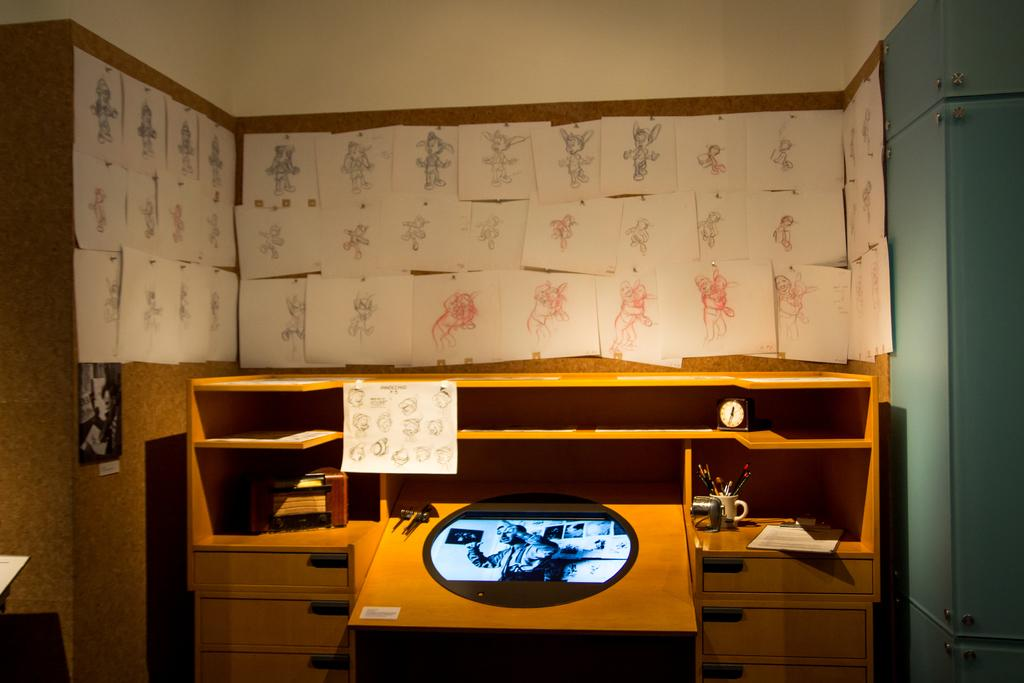What type of table is visible in the image? There is a wooden table in the image. What is on the table in the image? There are objects on the table. What can be seen on the wall in the background of the image? There are posters on the wall in the background of the image. What color is the sky in the image? There is no sky visible in the image, as it is an indoor scene with posters on the wall in the background. 